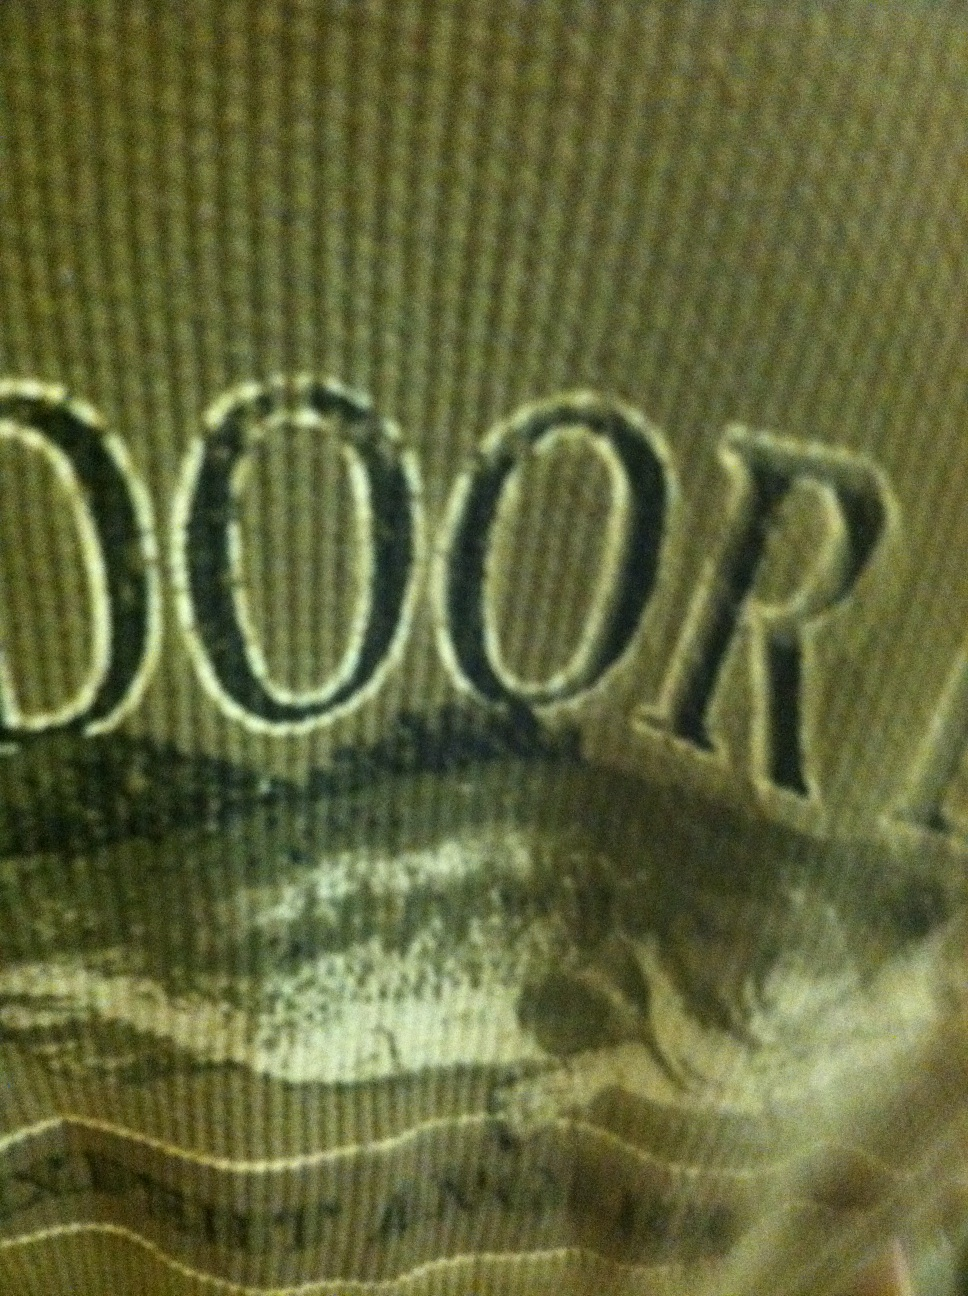Based on the image, could this shirt be part of an outdoor brand’s clothing line? Create a brand concept around it. Yes, this shirt could easily be part of an outdoor brand’s clothing line. Imagine a brand called 'Nature's Echo' that creates eco-friendly apparel for outdoor enthusiasts. Each piece, including this green shirt, is designed with sustainability in mind, using organic materials and featuring designs inspired by nature. The brand promotes an active lifestyle while raising awareness about environmental conservation. 